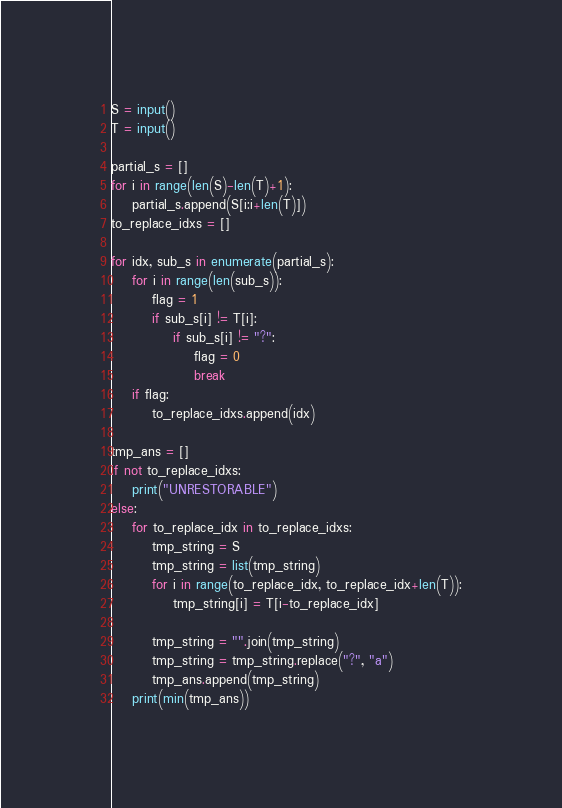<code> <loc_0><loc_0><loc_500><loc_500><_Python_>S = input()
T = input()

partial_s = []
for i in range(len(S)-len(T)+1):
    partial_s.append(S[i:i+len(T)])
to_replace_idxs = []

for idx, sub_s in enumerate(partial_s):
    for i in range(len(sub_s)):
        flag = 1
        if sub_s[i] != T[i]:
            if sub_s[i] != "?":
                flag = 0
                break
    if flag:
        to_replace_idxs.append(idx)

tmp_ans = []
if not to_replace_idxs:
    print("UNRESTORABLE")
else:
    for to_replace_idx in to_replace_idxs:
        tmp_string = S
        tmp_string = list(tmp_string)
        for i in range(to_replace_idx, to_replace_idx+len(T)):
            tmp_string[i] = T[i-to_replace_idx]
            
        tmp_string = "".join(tmp_string)
        tmp_string = tmp_string.replace("?", "a")
        tmp_ans.append(tmp_string)
    print(min(tmp_ans))</code> 